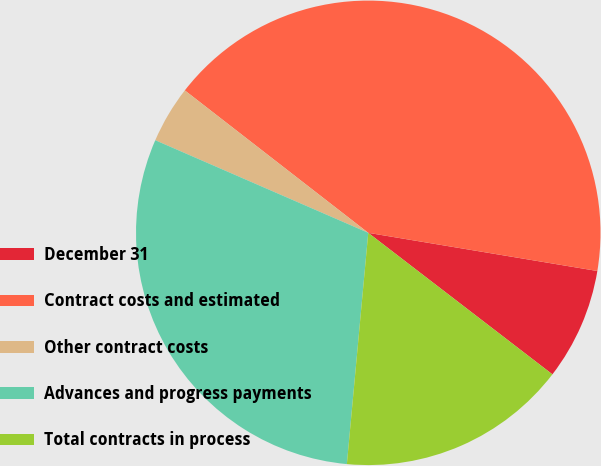Convert chart. <chart><loc_0><loc_0><loc_500><loc_500><pie_chart><fcel>December 31<fcel>Contract costs and estimated<fcel>Other contract costs<fcel>Advances and progress payments<fcel>Total contracts in process<nl><fcel>7.8%<fcel>42.12%<fcel>3.98%<fcel>30.06%<fcel>16.04%<nl></chart> 